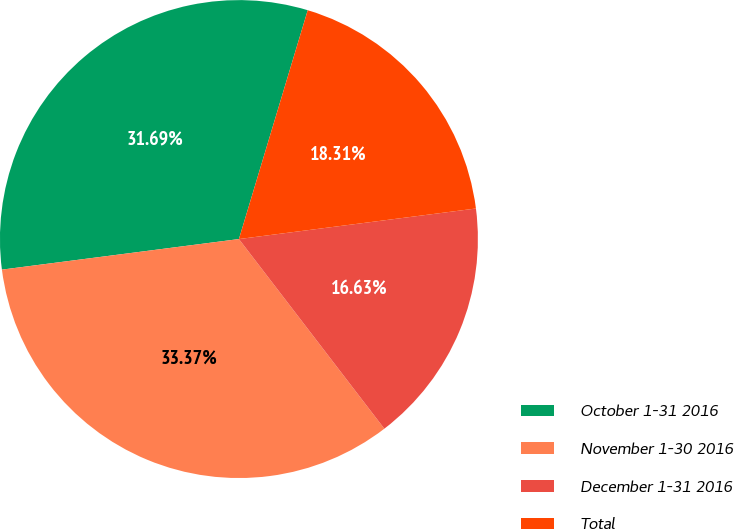<chart> <loc_0><loc_0><loc_500><loc_500><pie_chart><fcel>October 1-31 2016<fcel>November 1-30 2016<fcel>December 1-31 2016<fcel>Total<nl><fcel>31.69%<fcel>33.37%<fcel>16.63%<fcel>18.31%<nl></chart> 